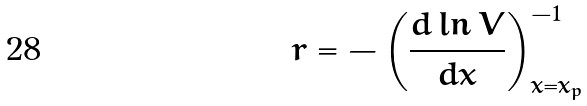<formula> <loc_0><loc_0><loc_500><loc_500>r = - \left ( \frac { d \ln V } { d x } \right ) _ { x = x _ { p } } ^ { - 1 }</formula> 